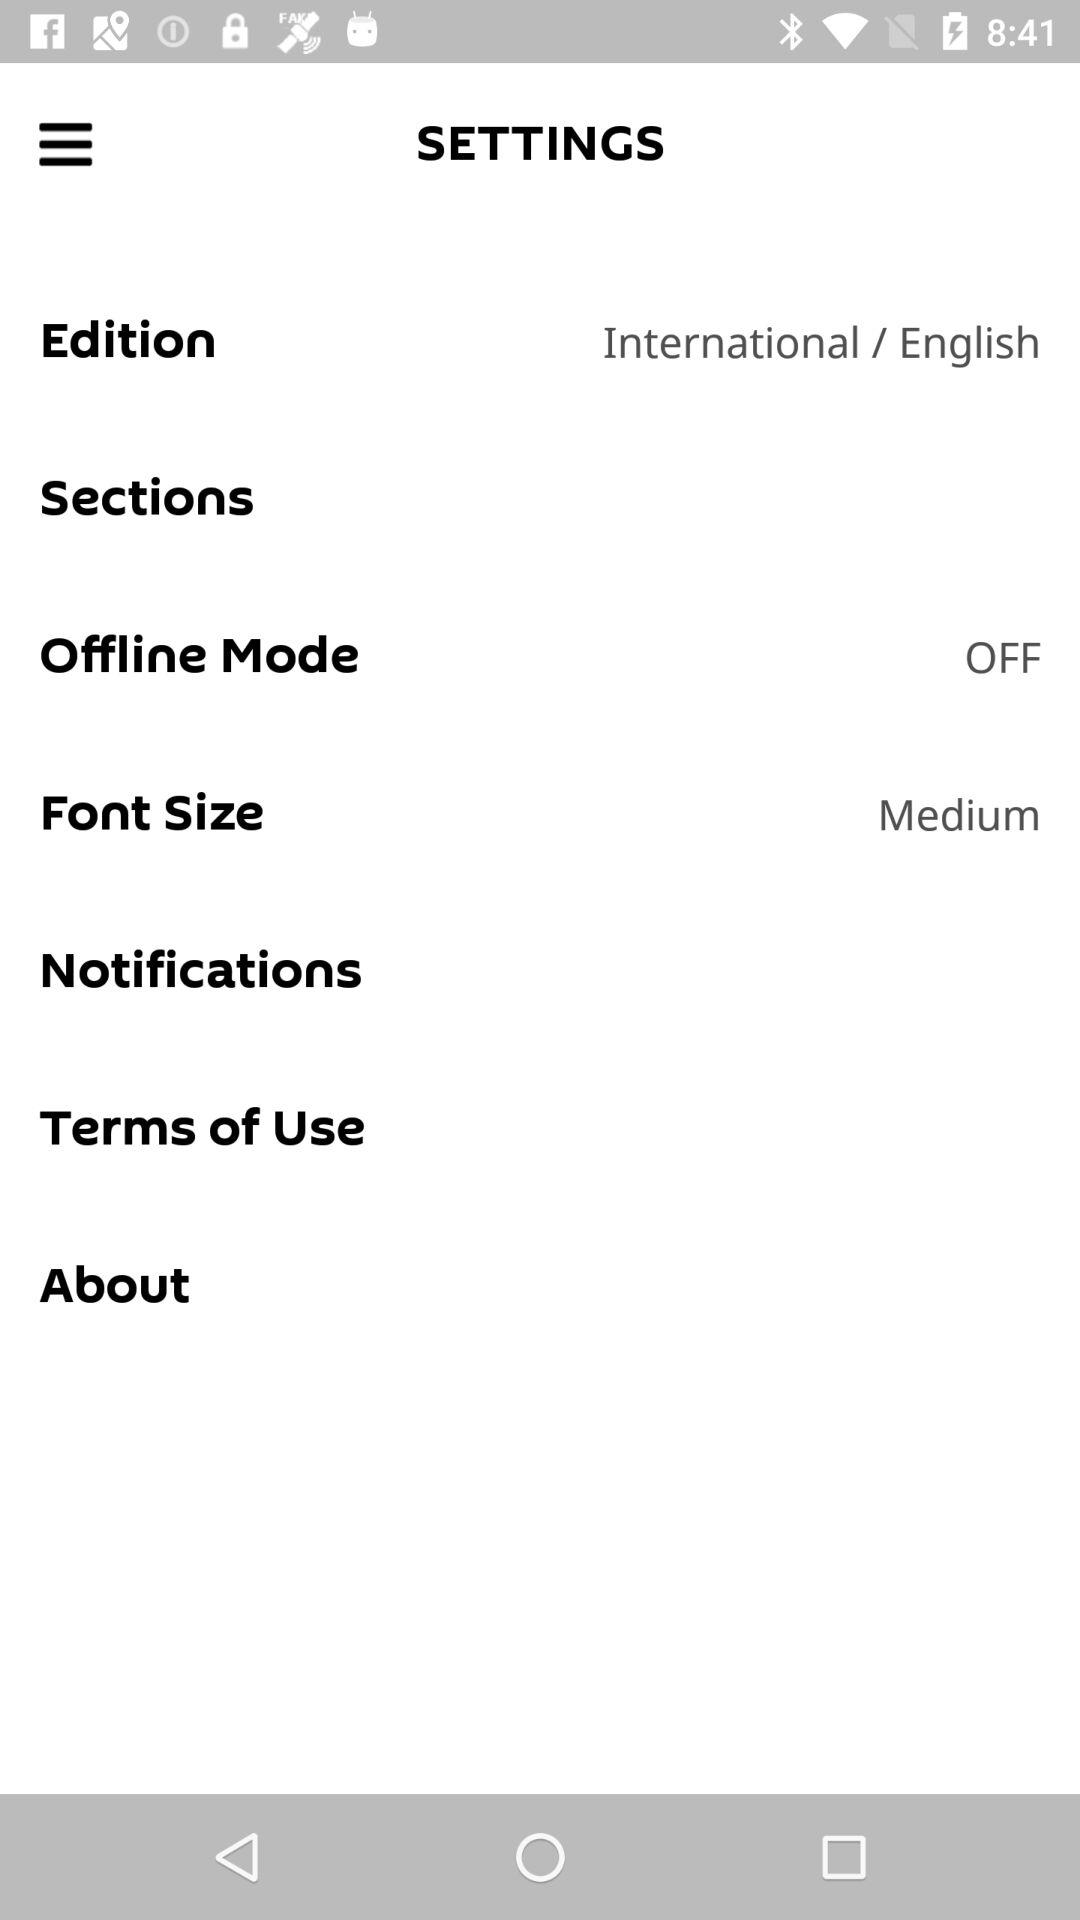What is the status of "Offline Mode"? The status of "Offline Mode" is "off". 